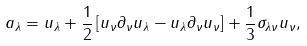<formula> <loc_0><loc_0><loc_500><loc_500>a _ { \lambda } = u _ { \lambda } + \frac { 1 } { 2 } \left [ u _ { \nu } \partial _ { \nu } u _ { \lambda } - u _ { \lambda } \partial _ { \nu } u _ { \nu } \right ] + \frac { 1 } { 3 } \sigma _ { \lambda \nu } u _ { \nu } ,</formula> 